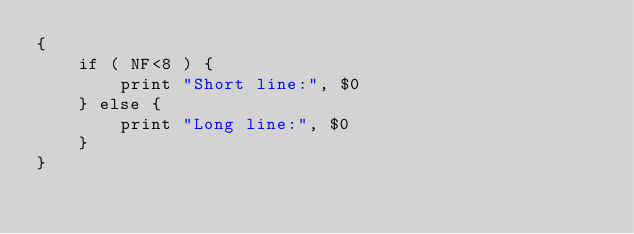Convert code to text. <code><loc_0><loc_0><loc_500><loc_500><_Awk_>{ 
	if ( NF<8 ) {
		print "Short line:", $0 
	} else { 
		print "Long line:", $0 
	} 
}
</code> 